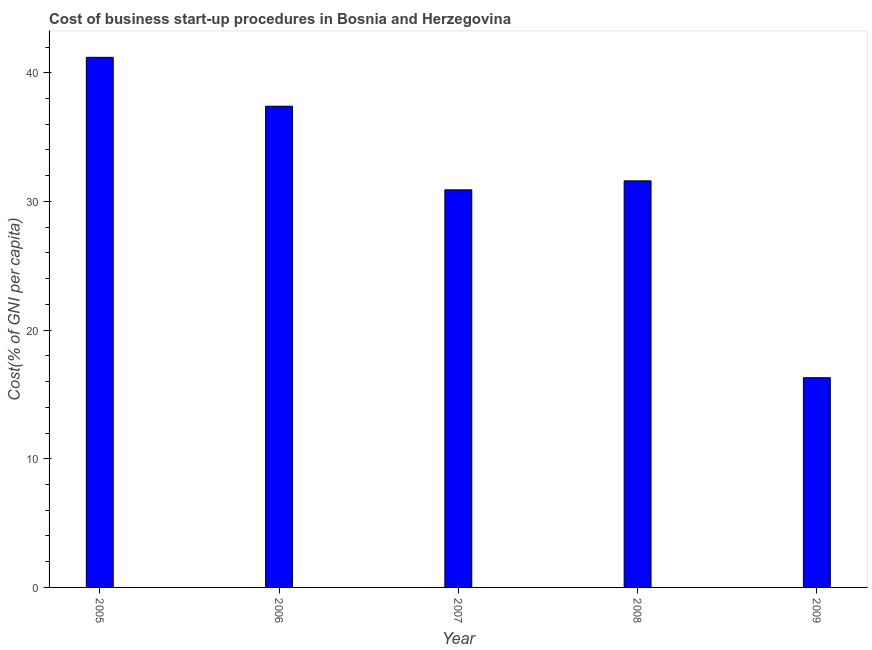Does the graph contain any zero values?
Provide a short and direct response. No. Does the graph contain grids?
Your answer should be compact. No. What is the title of the graph?
Make the answer very short. Cost of business start-up procedures in Bosnia and Herzegovina. What is the label or title of the Y-axis?
Provide a short and direct response. Cost(% of GNI per capita). What is the cost of business startup procedures in 2005?
Give a very brief answer. 41.2. Across all years, what is the maximum cost of business startup procedures?
Keep it short and to the point. 41.2. Across all years, what is the minimum cost of business startup procedures?
Keep it short and to the point. 16.3. What is the sum of the cost of business startup procedures?
Give a very brief answer. 157.4. What is the average cost of business startup procedures per year?
Make the answer very short. 31.48. What is the median cost of business startup procedures?
Provide a succinct answer. 31.6. In how many years, is the cost of business startup procedures greater than 34 %?
Keep it short and to the point. 2. What is the ratio of the cost of business startup procedures in 2005 to that in 2006?
Your response must be concise. 1.1. Is the difference between the cost of business startup procedures in 2005 and 2009 greater than the difference between any two years?
Offer a terse response. Yes. What is the difference between the highest and the second highest cost of business startup procedures?
Give a very brief answer. 3.8. What is the difference between the highest and the lowest cost of business startup procedures?
Your response must be concise. 24.9. Are all the bars in the graph horizontal?
Provide a short and direct response. No. What is the difference between two consecutive major ticks on the Y-axis?
Make the answer very short. 10. What is the Cost(% of GNI per capita) of 2005?
Your answer should be compact. 41.2. What is the Cost(% of GNI per capita) in 2006?
Offer a terse response. 37.4. What is the Cost(% of GNI per capita) of 2007?
Your answer should be very brief. 30.9. What is the Cost(% of GNI per capita) of 2008?
Ensure brevity in your answer.  31.6. What is the difference between the Cost(% of GNI per capita) in 2005 and 2006?
Keep it short and to the point. 3.8. What is the difference between the Cost(% of GNI per capita) in 2005 and 2007?
Your answer should be compact. 10.3. What is the difference between the Cost(% of GNI per capita) in 2005 and 2009?
Offer a very short reply. 24.9. What is the difference between the Cost(% of GNI per capita) in 2006 and 2007?
Ensure brevity in your answer.  6.5. What is the difference between the Cost(% of GNI per capita) in 2006 and 2009?
Give a very brief answer. 21.1. What is the difference between the Cost(% of GNI per capita) in 2007 and 2009?
Ensure brevity in your answer.  14.6. What is the difference between the Cost(% of GNI per capita) in 2008 and 2009?
Provide a succinct answer. 15.3. What is the ratio of the Cost(% of GNI per capita) in 2005 to that in 2006?
Provide a short and direct response. 1.1. What is the ratio of the Cost(% of GNI per capita) in 2005 to that in 2007?
Your response must be concise. 1.33. What is the ratio of the Cost(% of GNI per capita) in 2005 to that in 2008?
Keep it short and to the point. 1.3. What is the ratio of the Cost(% of GNI per capita) in 2005 to that in 2009?
Give a very brief answer. 2.53. What is the ratio of the Cost(% of GNI per capita) in 2006 to that in 2007?
Offer a terse response. 1.21. What is the ratio of the Cost(% of GNI per capita) in 2006 to that in 2008?
Ensure brevity in your answer.  1.18. What is the ratio of the Cost(% of GNI per capita) in 2006 to that in 2009?
Provide a short and direct response. 2.29. What is the ratio of the Cost(% of GNI per capita) in 2007 to that in 2008?
Keep it short and to the point. 0.98. What is the ratio of the Cost(% of GNI per capita) in 2007 to that in 2009?
Ensure brevity in your answer.  1.9. What is the ratio of the Cost(% of GNI per capita) in 2008 to that in 2009?
Ensure brevity in your answer.  1.94. 